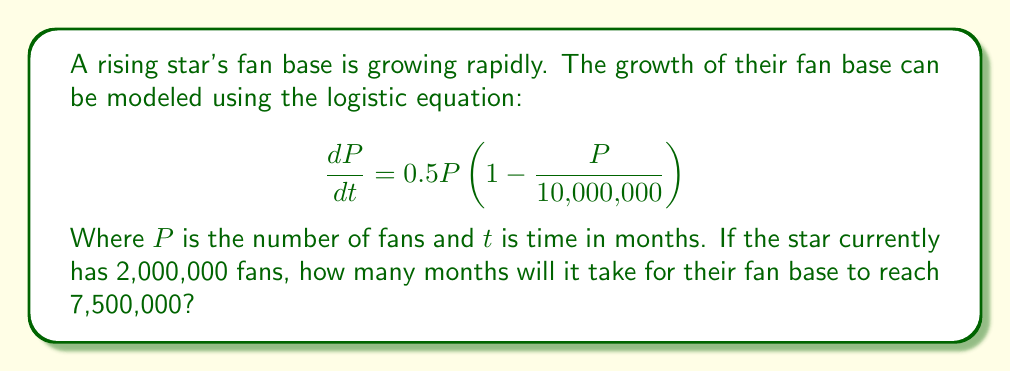Give your solution to this math problem. To solve this problem, we need to use the integrated form of the logistic equation:

$$P(t) = \frac{K}{1 + (\frac{K}{P_0} - 1)e^{-rt}}$$

Where:
$K$ is the carrying capacity (10,000,000 in this case)
$P_0$ is the initial population (2,000,000)
$r$ is the growth rate (0.5 in this case)
$t$ is the time in months

We want to find $t$ when $P(t) = 7,500,000$. Let's solve step by step:

1) Substitute the known values into the equation:

   $$7,500,000 = \frac{10,000,000}{1 + (\frac{10,000,000}{2,000,000} - 1)e^{-0.5t}}$$

2) Simplify:

   $$7,500,000 = \frac{10,000,000}{1 + 4e^{-0.5t}}$$

3) Multiply both sides by $(1 + 4e^{-0.5t})$:

   $$7,500,000(1 + 4e^{-0.5t}) = 10,000,000$$

4) Expand:

   $$7,500,000 + 30,000,000e^{-0.5t} = 10,000,000$$

5) Subtract 7,500,000 from both sides:

   $$30,000,000e^{-0.5t} = 2,500,000$$

6) Divide both sides by 30,000,000:

   $$e^{-0.5t} = \frac{1}{12}$$

7) Take the natural log of both sides:

   $$-0.5t = \ln(\frac{1}{12})$$

8) Solve for $t$:

   $$t = -\frac{2\ln(\frac{1}{12})}{0.5} = 2\ln(12) \approx 4.97$$
Answer: It will take approximately 4.97 months for the star's fan base to reach 7,500,000. 